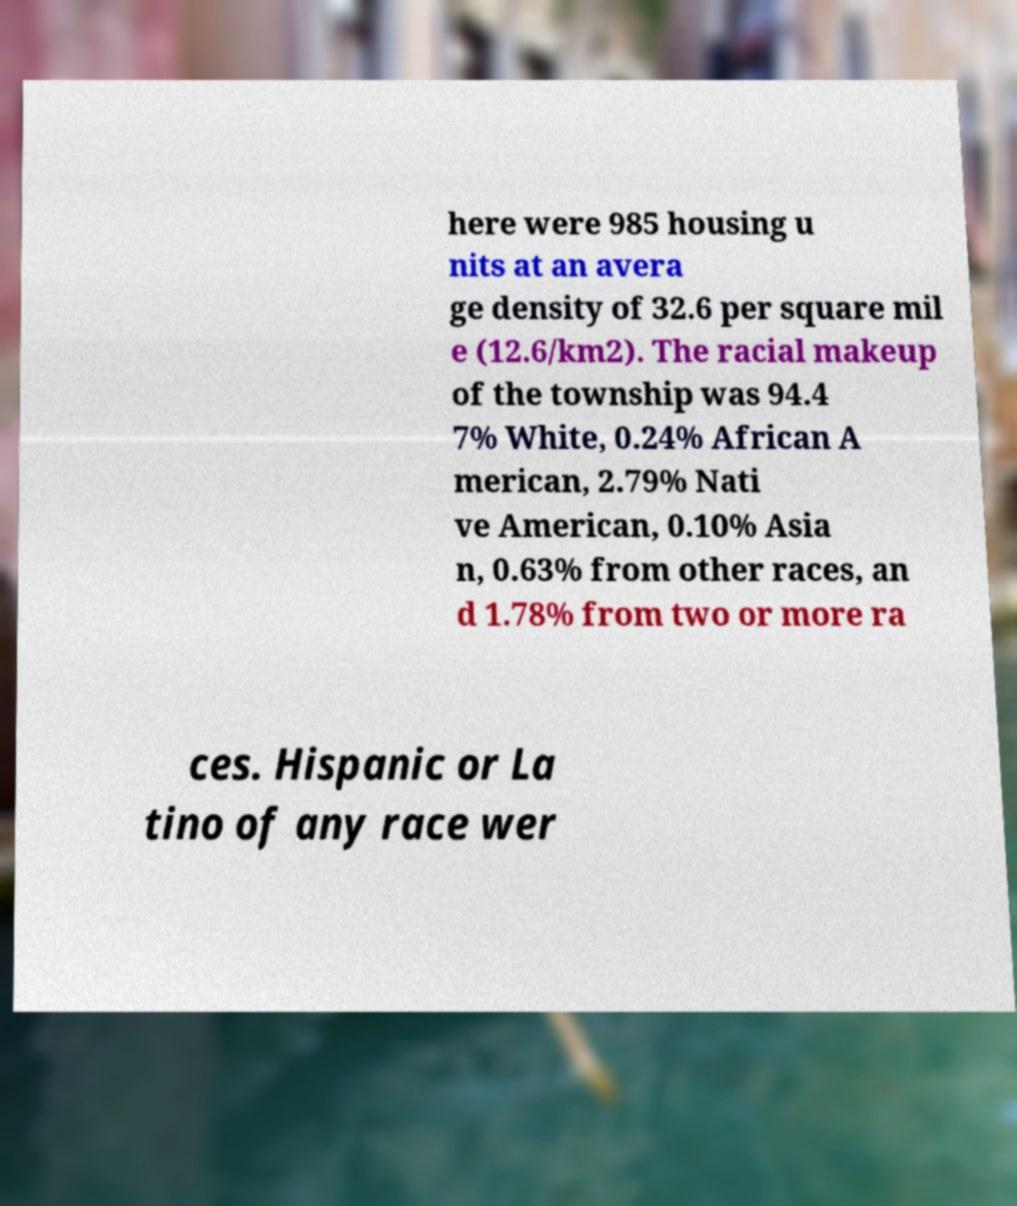For documentation purposes, I need the text within this image transcribed. Could you provide that? here were 985 housing u nits at an avera ge density of 32.6 per square mil e (12.6/km2). The racial makeup of the township was 94.4 7% White, 0.24% African A merican, 2.79% Nati ve American, 0.10% Asia n, 0.63% from other races, an d 1.78% from two or more ra ces. Hispanic or La tino of any race wer 